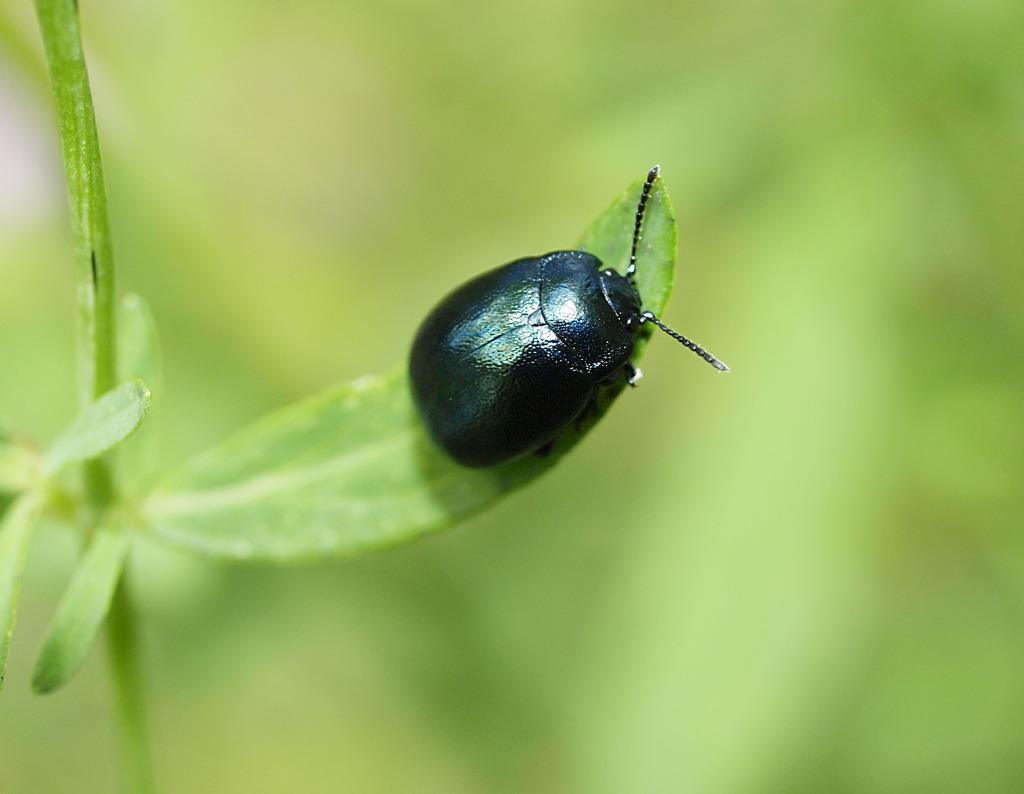Could you give a brief overview of what you see in this image? In this image I can see a black color insect on a leaf of a plant. The background is blurred. 